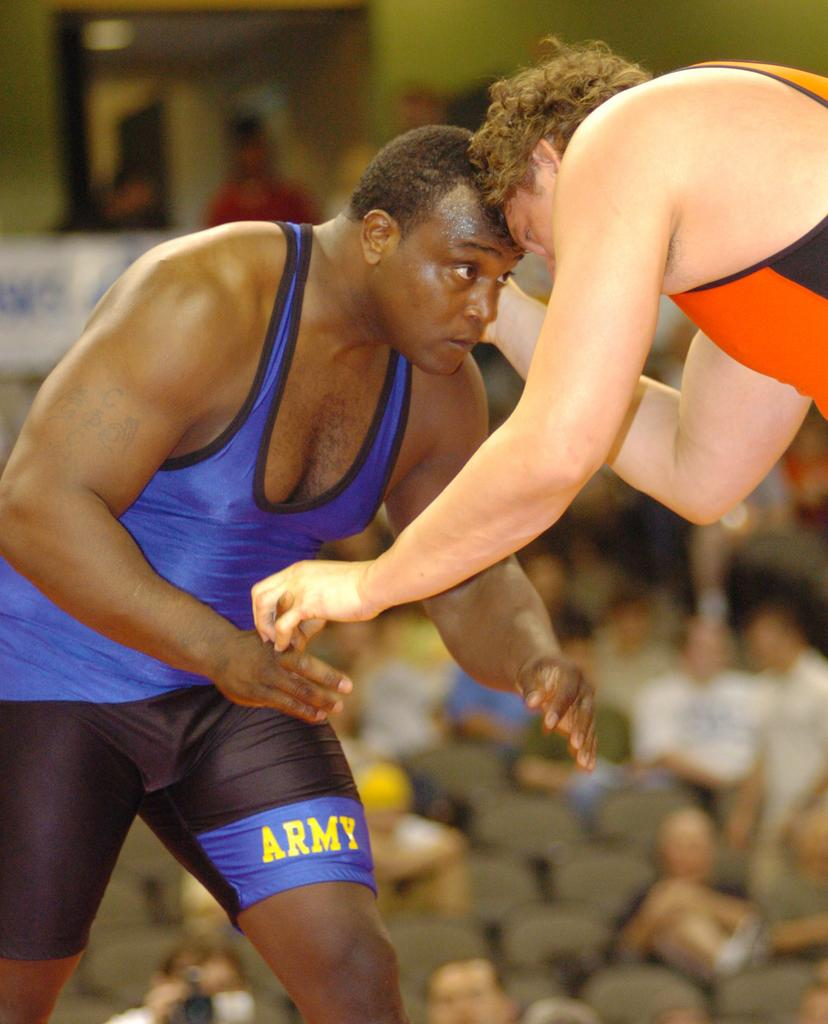<image>
Offer a succinct explanation of the picture presented. Two wrestlers going head to head with one of them saying ARMY on their leg. 